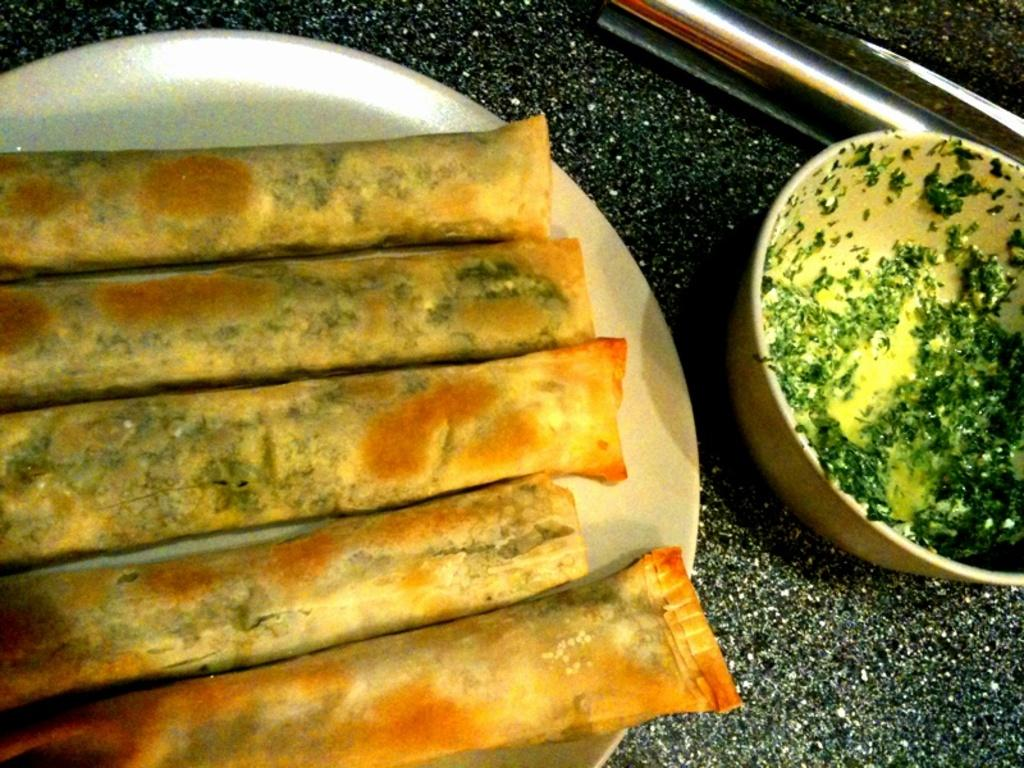What is the focus of the image? The image is zoomed in, so it is focused on a specific area or subject. What can be seen on the left side of the image? There is a plate containing food items on the left side of the image. What else is visible in the image besides the plate? There is a bowl visible in the image, as well as other objects. What is the color of the table in the image? The table in the image is black in color. Can you hear the mint leaves rustling in the image? There are no mint leaves present in the image, so it is not possible to hear them rustling. 